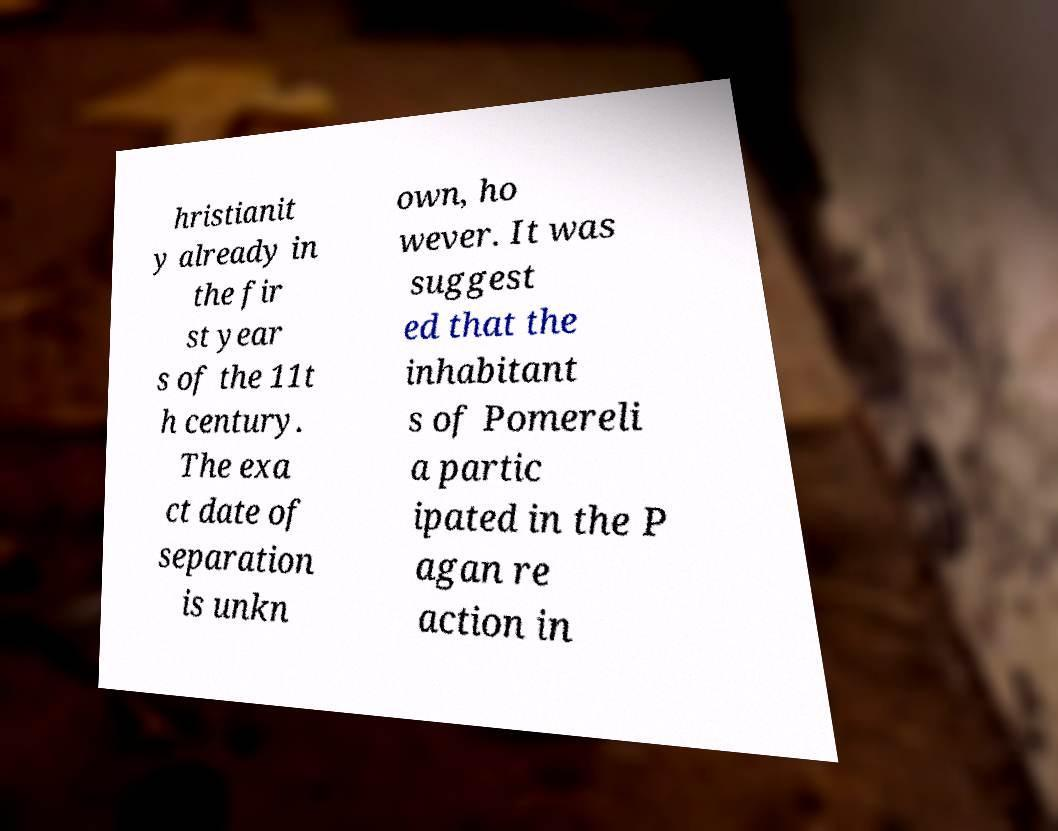There's text embedded in this image that I need extracted. Can you transcribe it verbatim? hristianit y already in the fir st year s of the 11t h century. The exa ct date of separation is unkn own, ho wever. It was suggest ed that the inhabitant s of Pomereli a partic ipated in the P agan re action in 